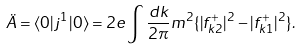Convert formula to latex. <formula><loc_0><loc_0><loc_500><loc_500>\ddot { A } = \langle 0 | j ^ { 1 } | 0 \rangle = 2 e \int \frac { d k } { 2 \pi } m ^ { 2 } \{ | f _ { k 2 } ^ { + } | ^ { 2 } - | f _ { k 1 } ^ { + } | ^ { 2 } \} .</formula> 